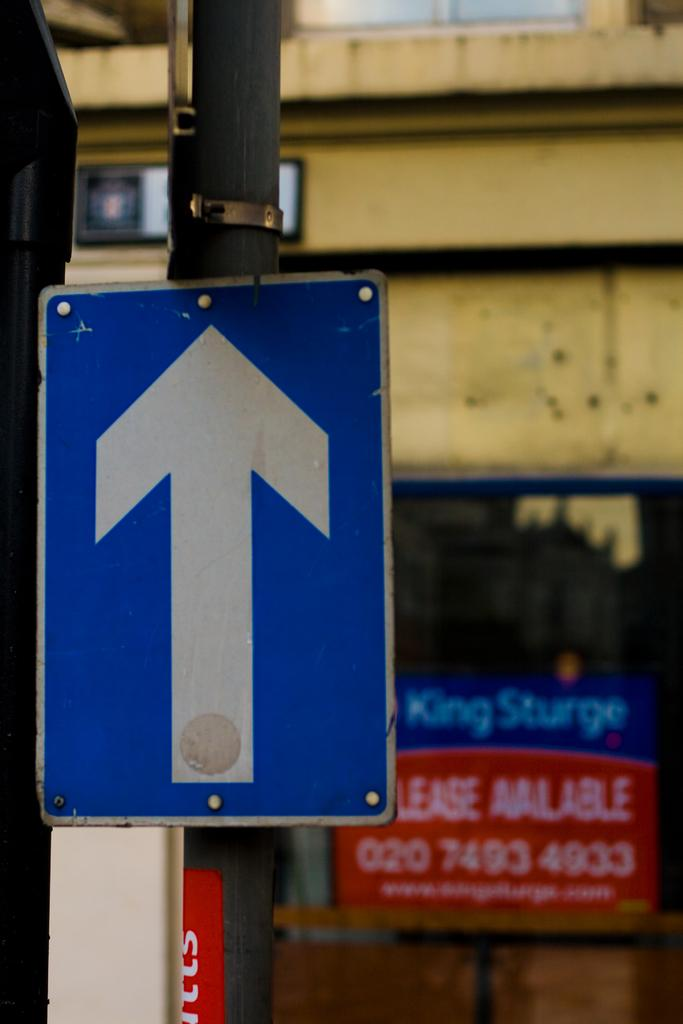<image>
Write a terse but informative summary of the picture. A go forward arrow pon a lampost is seen with a Lease Available sign in a shop window behind it. 